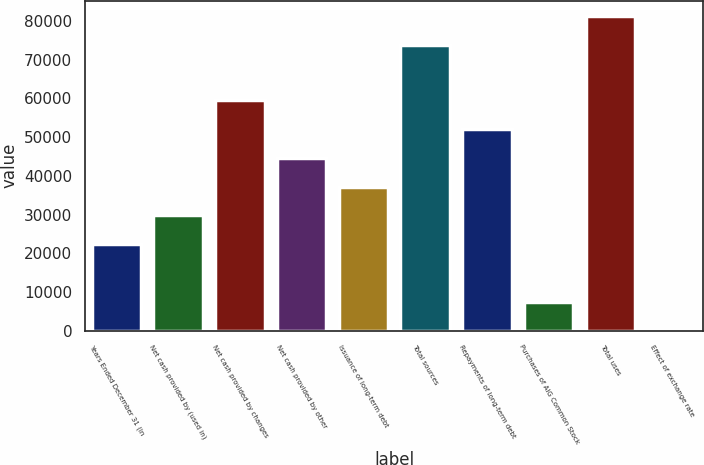Convert chart to OTSL. <chart><loc_0><loc_0><loc_500><loc_500><bar_chart><fcel>Years Ended December 31 (in<fcel>Net cash provided by (used in)<fcel>Net cash provided by changes<fcel>Net cash provided by other<fcel>Issuance of long-term debt<fcel>Total sources<fcel>Repayments of long-term debt<fcel>Purchases of AIG Common Stock<fcel>Total uses<fcel>Effect of exchange rate<nl><fcel>22330.7<fcel>29764.6<fcel>59500.2<fcel>44632.4<fcel>37198.5<fcel>73809<fcel>52066.3<fcel>7462.9<fcel>81242.9<fcel>29<nl></chart> 